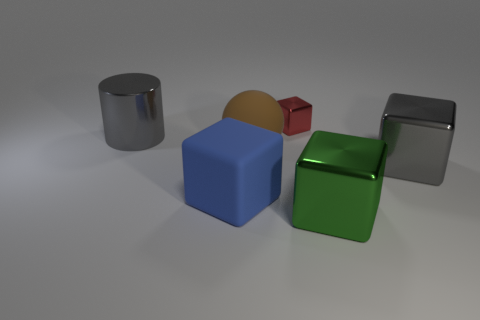The object that is the same color as the metallic cylinder is what shape?
Keep it short and to the point. Cube. What color is the block on the left side of the tiny red cube on the left side of the gray cube?
Make the answer very short. Blue. Are there more brown matte objects than gray metal things?
Your response must be concise. No. What number of blue cubes are the same size as the green metallic thing?
Provide a short and direct response. 1. Are the large blue thing and the gray thing on the left side of the red shiny thing made of the same material?
Offer a very short reply. No. Are there fewer big gray metallic cylinders than tiny gray cylinders?
Give a very brief answer. No. Is there any other thing of the same color as the large matte sphere?
Your answer should be very brief. No. There is another big thing that is made of the same material as the big blue thing; what is its shape?
Offer a very short reply. Sphere. There is a big metal object that is in front of the large gray shiny object on the right side of the tiny thing; how many large metal things are to the right of it?
Make the answer very short. 1. The large object that is on the left side of the big gray metal block and on the right side of the brown matte object has what shape?
Provide a succinct answer. Cube. 